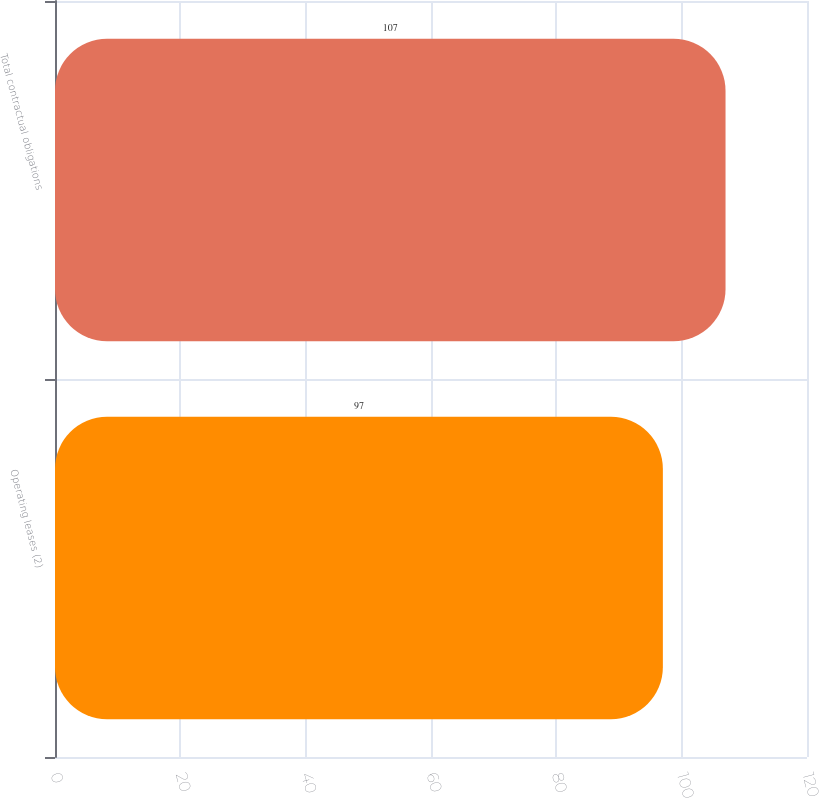Convert chart to OTSL. <chart><loc_0><loc_0><loc_500><loc_500><bar_chart><fcel>Operating leases (2)<fcel>Total contractual obligations<nl><fcel>97<fcel>107<nl></chart> 